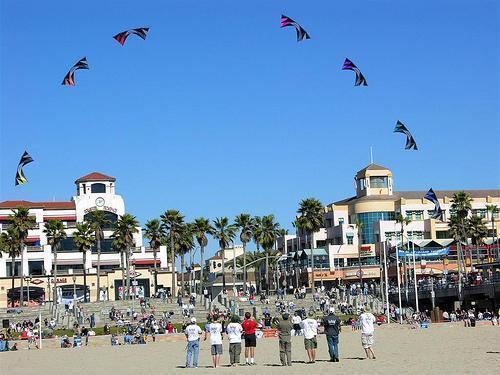The items the people are staring at are likely made of what?
Indicate the correct response by choosing from the four available options to answer the question.
Options: Mud, cloth, brick, stone. Cloth. 